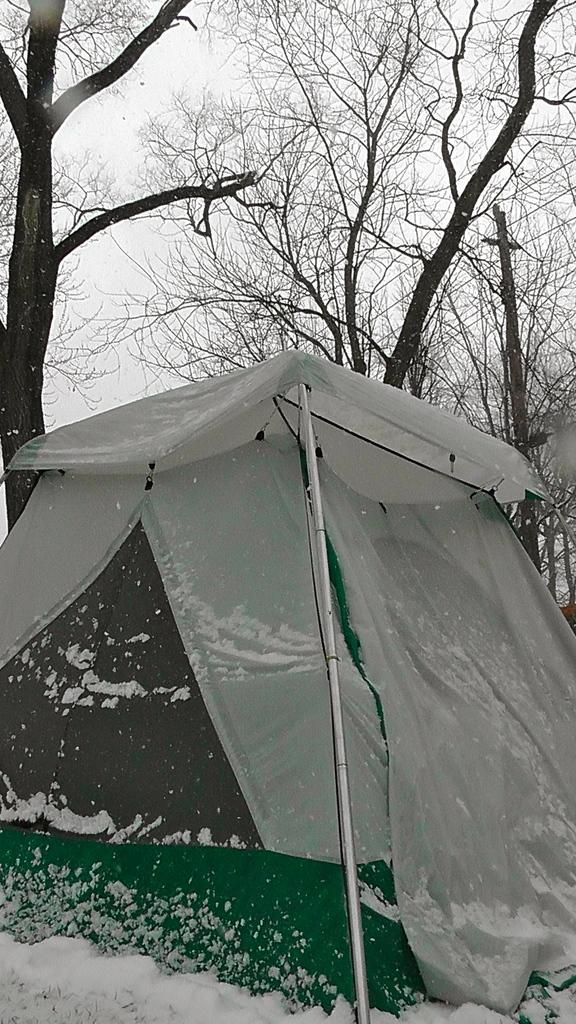What is the main structure in the center of the image? There is a tent in the center of the image. What can be seen in the background of the image? There are trees and the sky visible in the background of the image. What is the ground made of in the image? The ground is covered in snow at the bottom of the image. How many flags are present in the image? There are no flags visible in the image. What type of ice can be seen melting near the tent? There is no ice present in the image; it is covered in snow. 